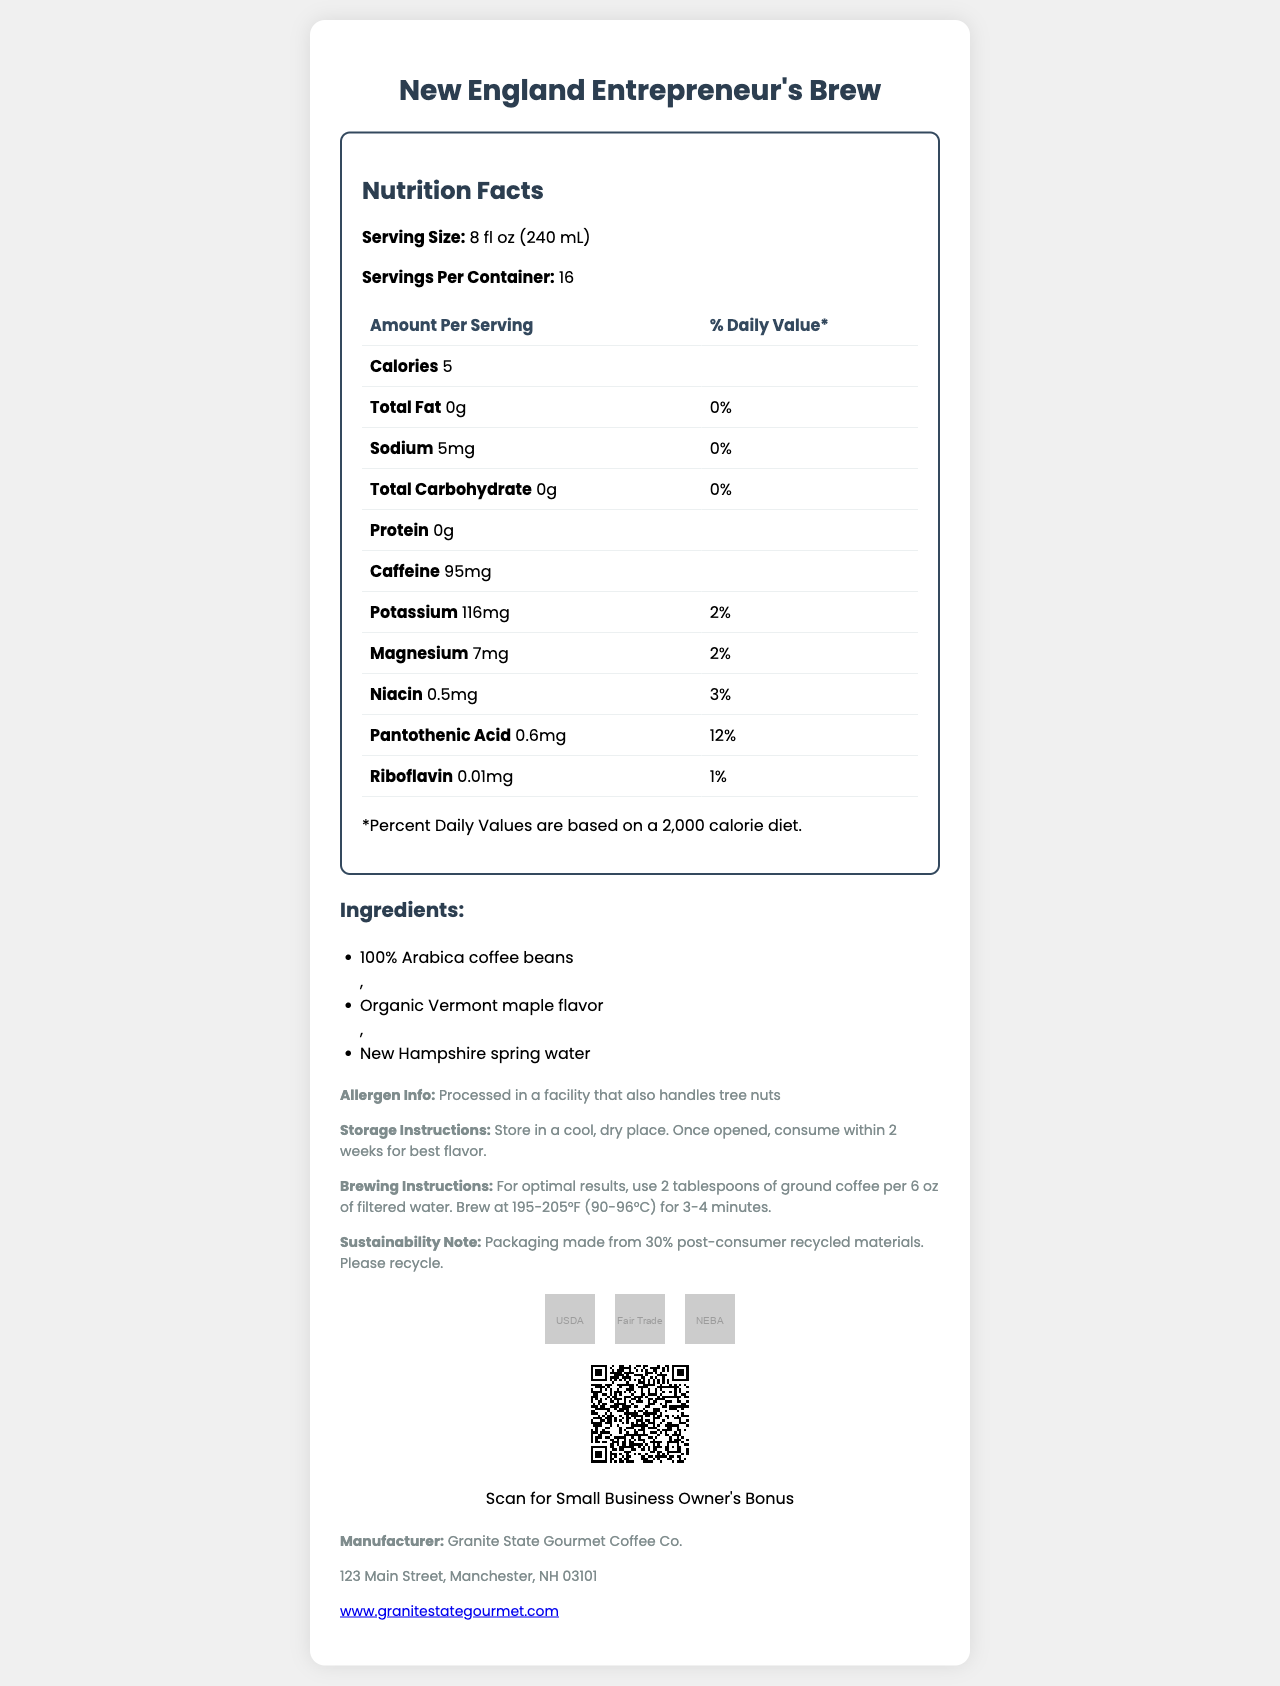what is the serving size of "New England Entrepreneur's Brew"? The serving size is provided at the top section of the Nutrition Facts panel.
Answer: 8 fl oz (240 mL) how many servings are there per container? The number of servings per container is listed under the serving size.
Answer: 16 what is the amount of caffeine per serving? The caffeine content is listed in the table under "Amount Per Serving".
Answer: 95mg how much potassium is present per serving? The potassium content is specified in the table under "Amount Per Serving".
Answer: 116mg what are the ingredients of the coffee blend? The ingredients are listed in the ingredients section.
Answer: 100% Arabica coffee beans, Organic Vermont maple flavor, New Hampshire spring water which of the following vitamins is present at the highest daily value percentage in the coffee blend? A. Niacin B. Pantothenic Acid C. Riboflavin Pantothenic Acid has a daily value of 12%, which is higher than Niacin (3%) and Riboflavin (1%).
Answer: B. Pantothenic Acid what allergens might the "New England Entrepreneur's Brew" contain? A. Dairy B. Tree nuts C. Gluten The allergen information mentioned in the document states that it is processed in a facility that also handles tree nuts.
Answer: B. Tree nuts is the "New England Entrepreneur's Brew" certified organic? The certification section shows the "USDA Organic" certification.
Answer: Yes summarize the main idea of the document. The document comprehensively details the nutritional content, certifications, and instructions related to the coffee, along with emphasizing its suitability for small business owners in New England.
Answer: The document provides the nutrition facts, ingredients, certifications, storage and brewing instructions, and additional information about the "New England Entrepreneur's Brew" coffee blend designed specifically for small business owners in New England. It also highlights the caffeine content and special benefits for business owners. what is the source of the water used in this coffee blend? The ingredients list includes New Hampshire spring water.
Answer: New Hampshire spring water how many calories are there per serving? The calorie content per serving is listed under the serving size.
Answer: 5 what is the manufacturer's website URL? The website URL is included in the manufacturer information section at the end of the document.
Answer: www.granitestategourmet.com are there any carbohydrates in this coffee blend? The total carbohydrate content is listed as 0g per serving.
Answer: No what is the storage instruction provided? The storage instructions are mentioned in the additional information section.
Answer: Store in a cool, dry place. Once opened, consume within 2 weeks for best flavor. where is the manufacturer of "New England Entrepreneur's Brew" located? The manufacturer’s address is provided in the manufacturer information section.
Answer: 123 Main Street, Manchester, NH 03101 what role does the QR code play in the document? The QR code is mentioned in the business owner bonus section, stating it leads to productivity tips and networking events for small business owners.
Answer: Provides exclusive access to Small Business Owner's productivity tips and networking events in New England is there any information about protein content in the coffee blend? The protein content is listed as 0g in the nutrition facts table.
Answer: Yes how does the document address sustainability? The sustainability note at the end of the document mentions the use of recycled materials for packaging.
Answer: The packaging is made from 30% post-consumer recycled materials. is the coffee blend suitable for people avoiding caffeine? The coffee blend contains 95mg of caffeine per serving, which is relatively high.
Answer: No what is the ratio of tablespoons of ground coffee to ounces of water for brewing the coffee? The brewing instructions specify this ratio for optimal brewing results.
Answer: 2 tablespoons of ground coffee per 6 oz of filtered water which nutrient has the smallest percentage daily value? Riboflavin has only 1% of the daily value, the smallest percentage listed in the document.
Answer: Riboflavin what is the specific purpose of "New England Entrepreneur's Brew"? The document title and context suggest that this gourmet coffee blend is targeted at small business owners in New England.
Answer: The coffee blend is created specifically for small business owners in New England. who is the business owner bonus aimed at? A. Fitness Enthusiasts B. Entrepreneurs in New England C. College Students The business owner bonus is aimed at providing exclusive access to productivity tips and networking events for small business owners in New England.
Answer: B. Entrepreneurs in New England what are the certifications received by "New England Entrepreneur's Brew"? The certifications are listed in the certifications section, accompanied by corresponding logos.
Answer: USDA Organic, Fair Trade Certified, New England Business Association Approved how is "New England Entrepreneur's Brew" beneficial for small business owners? The QR code offers exclusive content for small business owners, enhancing their productivity and networking opportunities.
Answer: The blend offers a QR code that provides access to productivity tips and networking events. does the document mention the price of "New England Entrepreneur's Brew"? The document does not mention the pricing information.
Answer: Not enough information 